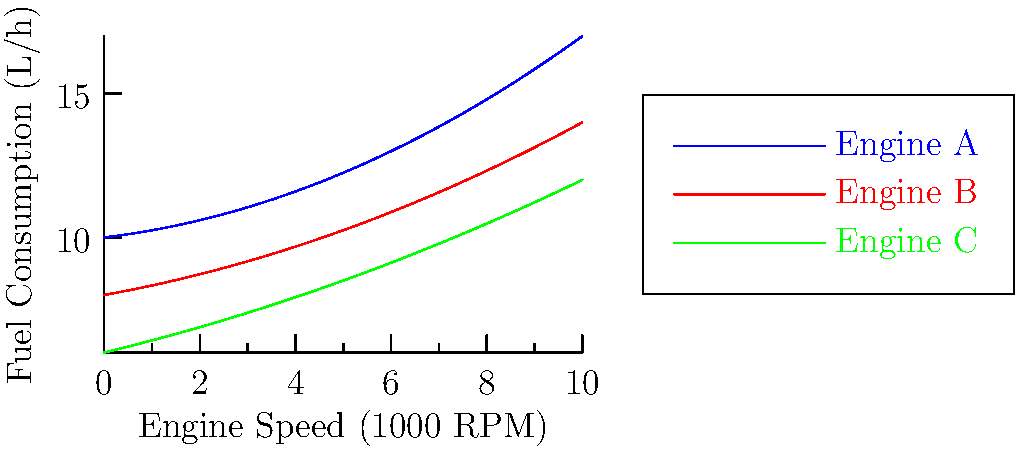Based on the performance curves shown in the graph, which engine type would be most suitable for a low-impact eco-tourism boat in the Amazon, considering the need to minimize fuel consumption and environmental impact at typical cruising speeds (around 3000-5000 RPM)? To determine the most suitable engine for a low-impact eco-tourism boat in the Amazon, we need to analyze the fuel consumption of each engine type at typical cruising speeds (3000-5000 RPM). Let's break down the analysis:

1. Identify the engines:
   - Blue curve: Engine A
   - Red curve: Engine B
   - Green curve: Engine C

2. Examine the fuel consumption at the given RPM range:
   - At 3000 RPM (x = 3 on the graph):
     Engine A: ~12 L/h
     Engine B: ~11 L/h
     Engine C: ~10 L/h

   - At 5000 RPM (x = 5 on the graph):
     Engine A: ~15 L/h
     Engine B: ~13 L/h
     Engine C: ~12 L/h

3. Compare the overall performance:
   Engine C (green curve) consistently shows the lowest fuel consumption across the entire RPM range, including the typical cruising speeds.

4. Consider the environmental impact:
   Lower fuel consumption directly correlates with reduced emissions and a smaller environmental footprint, which aligns with the goals of eco-tourism and minimizing impact on the Amazon ecosystem.

5. Evaluate the sociocultural context:
   Choosing the most fuel-efficient engine demonstrates a commitment to environmental conservation, which can positively influence local communities and tourists' perceptions of the eco-tourism operation.

Based on this analysis, Engine C would be the most suitable choice for a low-impact eco-tourism boat in the Amazon, as it offers the lowest fuel consumption and, consequently, the least environmental impact at typical cruising speeds.
Answer: Engine C 